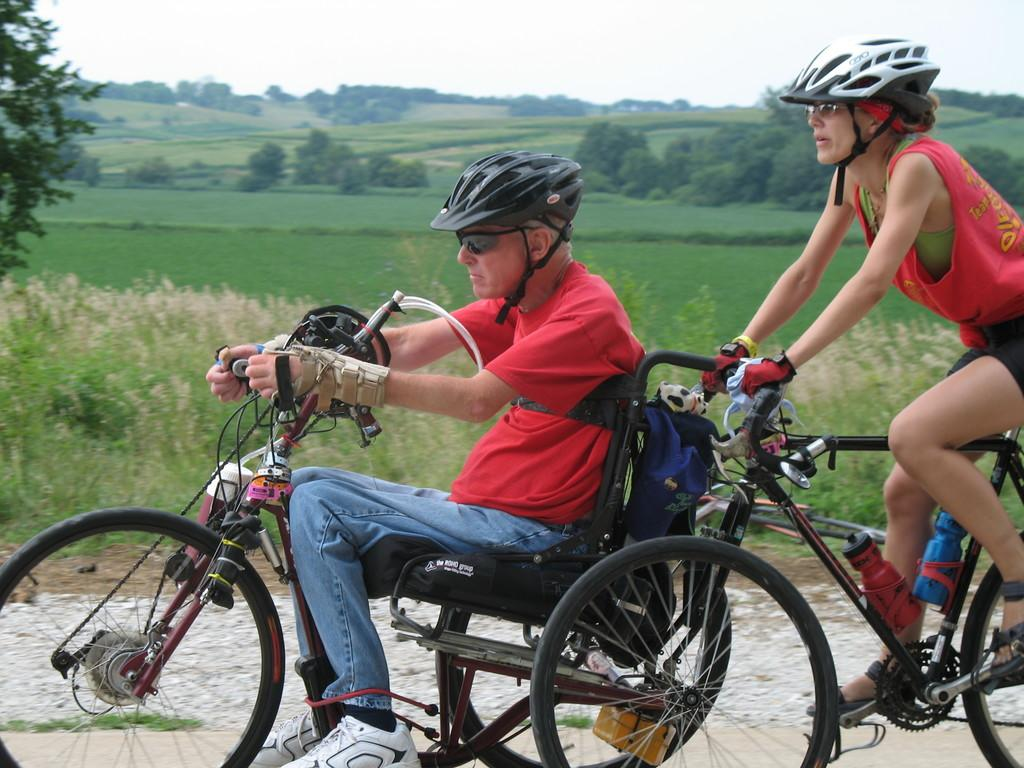What is the man doing in the image? The man is on a cycle in the image. What is the woman doing in the image? The woman is also on a cycle in the image. Where are the man and woman located in the image? They are on a path in the image. What can be seen in the background of the image? There is grass, trees, and the sky visible in the background of the image. What type of treatment is the man receiving for his injured leg in the image? There is no indication in the image that the man has an injured leg or is receiving any treatment. 